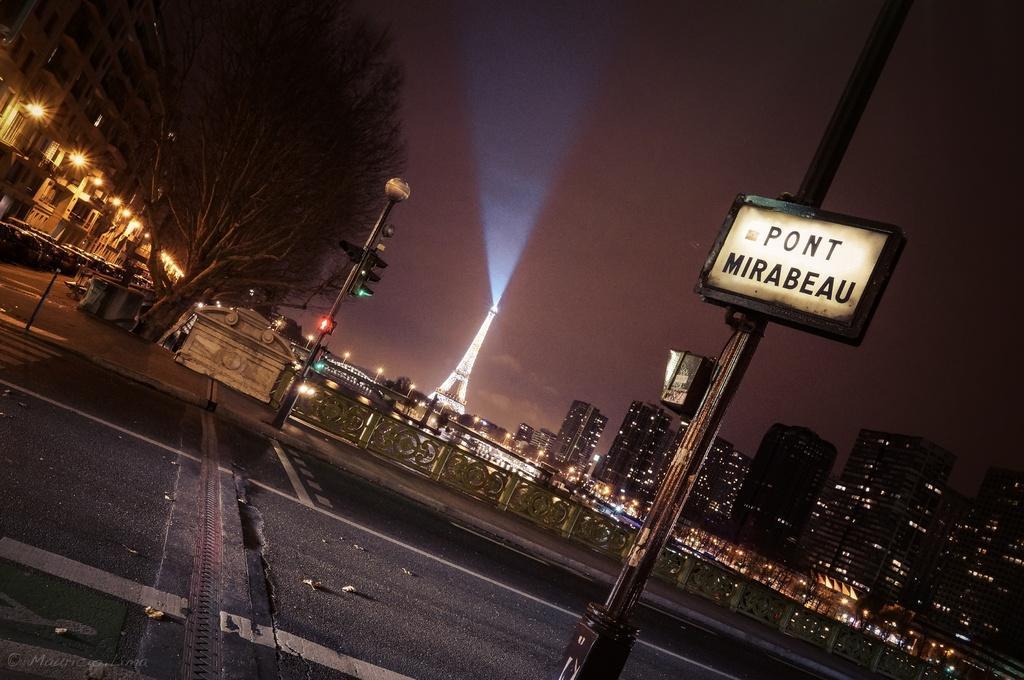Could you give a brief overview of what you see in this image? In this picture we can see a few leaves on the road. There is a board on the pole. We can see a fence, lights, tree, Eiffel tower and a few buildings in the background. 